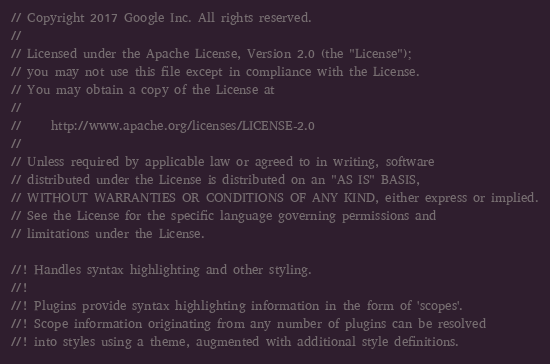<code> <loc_0><loc_0><loc_500><loc_500><_Rust_>// Copyright 2017 Google Inc. All rights reserved.
//
// Licensed under the Apache License, Version 2.0 (the "License");
// you may not use this file except in compliance with the License.
// You may obtain a copy of the License at
//
//     http://www.apache.org/licenses/LICENSE-2.0
//
// Unless required by applicable law or agreed to in writing, software
// distributed under the License is distributed on an "AS IS" BASIS,
// WITHOUT WARRANTIES OR CONDITIONS OF ANY KIND, either express or implied.
// See the License for the specific language governing permissions and
// limitations under the License.

//! Handles syntax highlighting and other styling.
//!
//! Plugins provide syntax highlighting information in the form of 'scopes'.
//! Scope information originating from any number of plugins can be resolved
//! into styles using a theme, augmented with additional style definitions.
</code> 